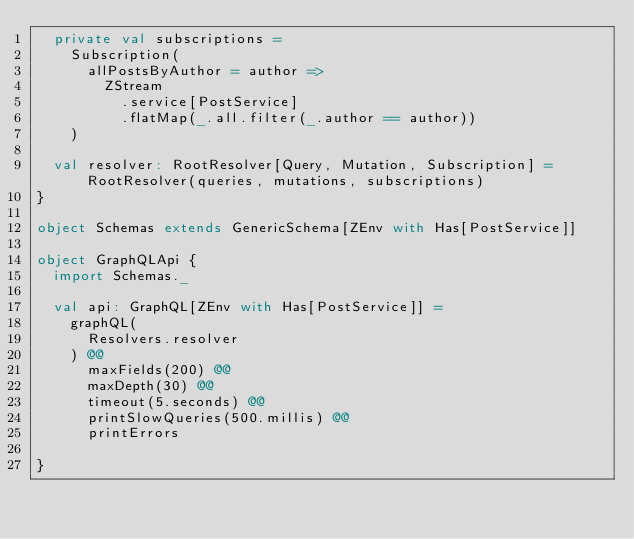<code> <loc_0><loc_0><loc_500><loc_500><_Scala_>  private val subscriptions =
    Subscription(
      allPostsByAuthor = author =>
        ZStream
          .service[PostService]
          .flatMap(_.all.filter(_.author == author))
    )

  val resolver: RootResolver[Query, Mutation, Subscription] = RootResolver(queries, mutations, subscriptions)
}

object Schemas extends GenericSchema[ZEnv with Has[PostService]]

object GraphQLApi {
  import Schemas._

  val api: GraphQL[ZEnv with Has[PostService]] =
    graphQL(
      Resolvers.resolver
    ) @@
      maxFields(200) @@
      maxDepth(30) @@
      timeout(5.seconds) @@
      printSlowQueries(500.millis) @@
      printErrors

}
</code> 